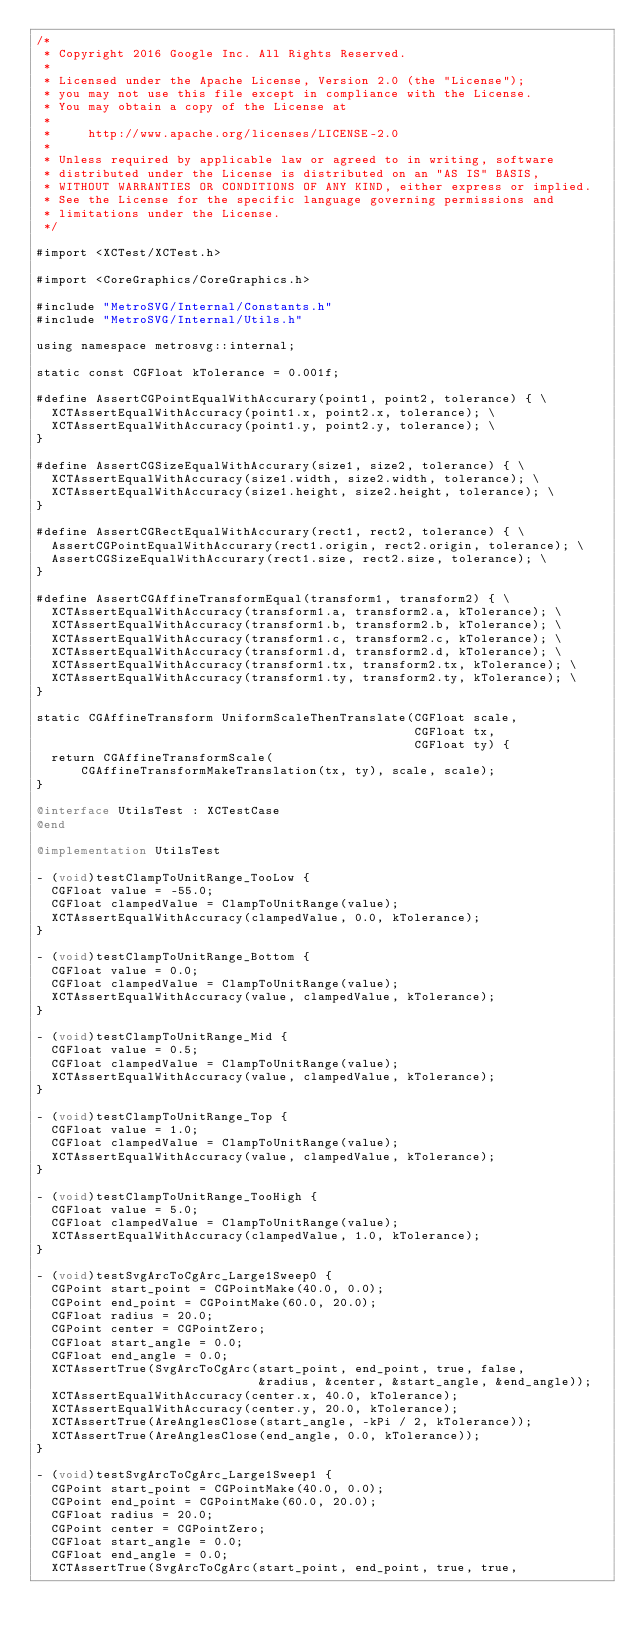Convert code to text. <code><loc_0><loc_0><loc_500><loc_500><_ObjectiveC_>/*
 * Copyright 2016 Google Inc. All Rights Reserved.
 *
 * Licensed under the Apache License, Version 2.0 (the "License");
 * you may not use this file except in compliance with the License.
 * You may obtain a copy of the License at
 *
 *     http://www.apache.org/licenses/LICENSE-2.0
 *
 * Unless required by applicable law or agreed to in writing, software
 * distributed under the License is distributed on an "AS IS" BASIS,
 * WITHOUT WARRANTIES OR CONDITIONS OF ANY KIND, either express or implied.
 * See the License for the specific language governing permissions and
 * limitations under the License.
 */

#import <XCTest/XCTest.h>

#import <CoreGraphics/CoreGraphics.h>

#include "MetroSVG/Internal/Constants.h"
#include "MetroSVG/Internal/Utils.h"

using namespace metrosvg::internal;

static const CGFloat kTolerance = 0.001f;

#define AssertCGPointEqualWithAccurary(point1, point2, tolerance) { \
  XCTAssertEqualWithAccuracy(point1.x, point2.x, tolerance); \
  XCTAssertEqualWithAccuracy(point1.y, point2.y, tolerance); \
}

#define AssertCGSizeEqualWithAccurary(size1, size2, tolerance) { \
  XCTAssertEqualWithAccuracy(size1.width, size2.width, tolerance); \
  XCTAssertEqualWithAccuracy(size1.height, size2.height, tolerance); \
}

#define AssertCGRectEqualWithAccurary(rect1, rect2, tolerance) { \
  AssertCGPointEqualWithAccurary(rect1.origin, rect2.origin, tolerance); \
  AssertCGSizeEqualWithAccurary(rect1.size, rect2.size, tolerance); \
}

#define AssertCGAffineTransformEqual(transform1, transform2) { \
  XCTAssertEqualWithAccuracy(transform1.a, transform2.a, kTolerance); \
  XCTAssertEqualWithAccuracy(transform1.b, transform2.b, kTolerance); \
  XCTAssertEqualWithAccuracy(transform1.c, transform2.c, kTolerance); \
  XCTAssertEqualWithAccuracy(transform1.d, transform2.d, kTolerance); \
  XCTAssertEqualWithAccuracy(transform1.tx, transform2.tx, kTolerance); \
  XCTAssertEqualWithAccuracy(transform1.ty, transform2.ty, kTolerance); \
}

static CGAffineTransform UniformScaleThenTranslate(CGFloat scale,
                                                   CGFloat tx,
                                                   CGFloat ty) {
  return CGAffineTransformScale(
      CGAffineTransformMakeTranslation(tx, ty), scale, scale);
}

@interface UtilsTest : XCTestCase
@end

@implementation UtilsTest

- (void)testClampToUnitRange_TooLow {
  CGFloat value = -55.0;
  CGFloat clampedValue = ClampToUnitRange(value);
  XCTAssertEqualWithAccuracy(clampedValue, 0.0, kTolerance);
}

- (void)testClampToUnitRange_Bottom {
  CGFloat value = 0.0;
  CGFloat clampedValue = ClampToUnitRange(value);
  XCTAssertEqualWithAccuracy(value, clampedValue, kTolerance);
}

- (void)testClampToUnitRange_Mid {
  CGFloat value = 0.5;
  CGFloat clampedValue = ClampToUnitRange(value);
  XCTAssertEqualWithAccuracy(value, clampedValue, kTolerance);
}

- (void)testClampToUnitRange_Top {
  CGFloat value = 1.0;
  CGFloat clampedValue = ClampToUnitRange(value);
  XCTAssertEqualWithAccuracy(value, clampedValue, kTolerance);
}

- (void)testClampToUnitRange_TooHigh {
  CGFloat value = 5.0;
  CGFloat clampedValue = ClampToUnitRange(value);
  XCTAssertEqualWithAccuracy(clampedValue, 1.0, kTolerance);
}

- (void)testSvgArcToCgArc_Large1Sweep0 {
  CGPoint start_point = CGPointMake(40.0, 0.0);
  CGPoint end_point = CGPointMake(60.0, 20.0);
  CGFloat radius = 20.0;
  CGPoint center = CGPointZero;
  CGFloat start_angle = 0.0;
  CGFloat end_angle = 0.0;
  XCTAssertTrue(SvgArcToCgArc(start_point, end_point, true, false,
                              &radius, &center, &start_angle, &end_angle));
  XCTAssertEqualWithAccuracy(center.x, 40.0, kTolerance);
  XCTAssertEqualWithAccuracy(center.y, 20.0, kTolerance);
  XCTAssertTrue(AreAnglesClose(start_angle, -kPi / 2, kTolerance));
  XCTAssertTrue(AreAnglesClose(end_angle, 0.0, kTolerance));
}

- (void)testSvgArcToCgArc_Large1Sweep1 {
  CGPoint start_point = CGPointMake(40.0, 0.0);
  CGPoint end_point = CGPointMake(60.0, 20.0);
  CGFloat radius = 20.0;
  CGPoint center = CGPointZero;
  CGFloat start_angle = 0.0;
  CGFloat end_angle = 0.0;
  XCTAssertTrue(SvgArcToCgArc(start_point, end_point, true, true,</code> 